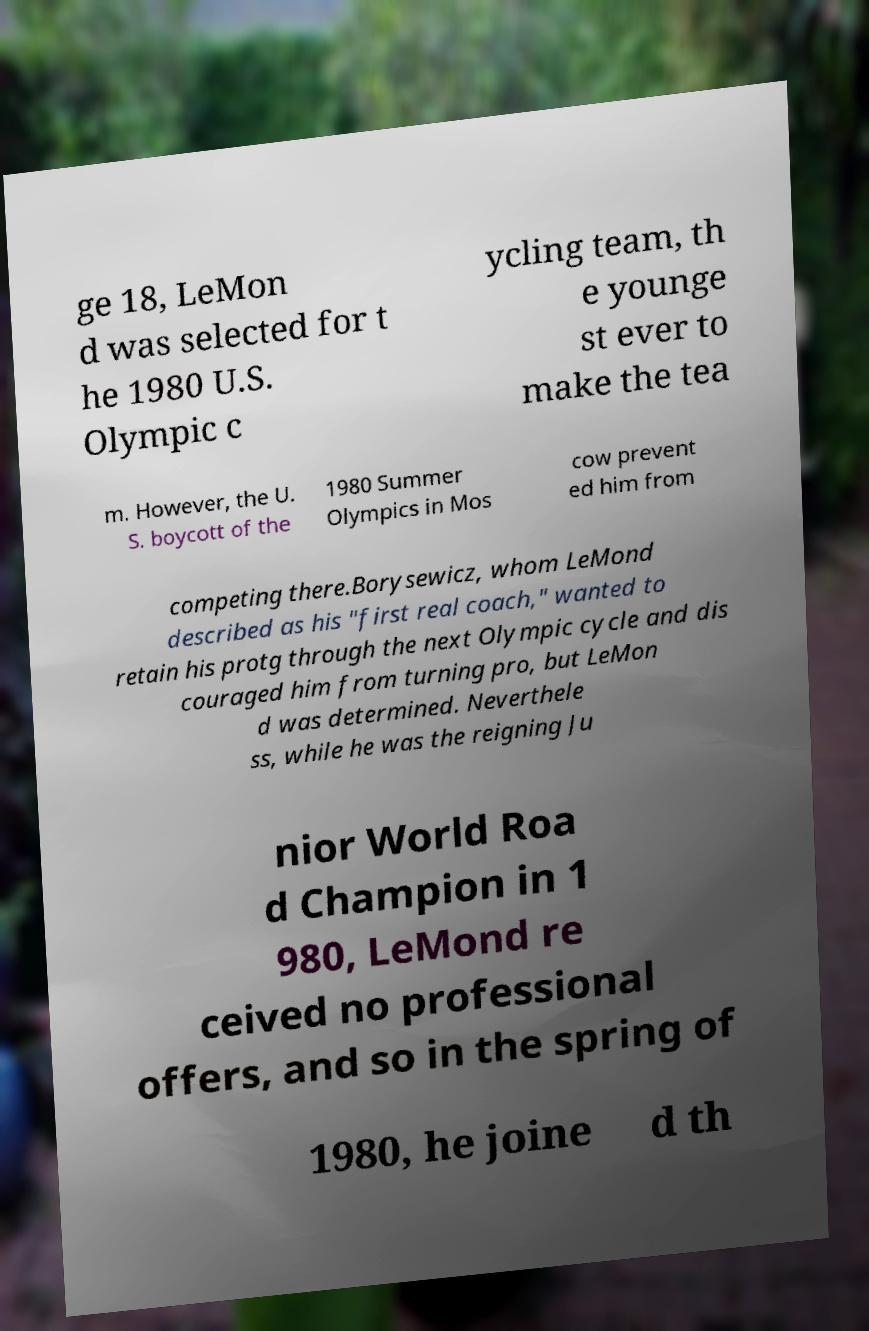Can you accurately transcribe the text from the provided image for me? ge 18, LeMon d was selected for t he 1980 U.S. Olympic c ycling team, th e younge st ever to make the tea m. However, the U. S. boycott of the 1980 Summer Olympics in Mos cow prevent ed him from competing there.Borysewicz, whom LeMond described as his "first real coach," wanted to retain his protg through the next Olympic cycle and dis couraged him from turning pro, but LeMon d was determined. Neverthele ss, while he was the reigning Ju nior World Roa d Champion in 1 980, LeMond re ceived no professional offers, and so in the spring of 1980, he joine d th 